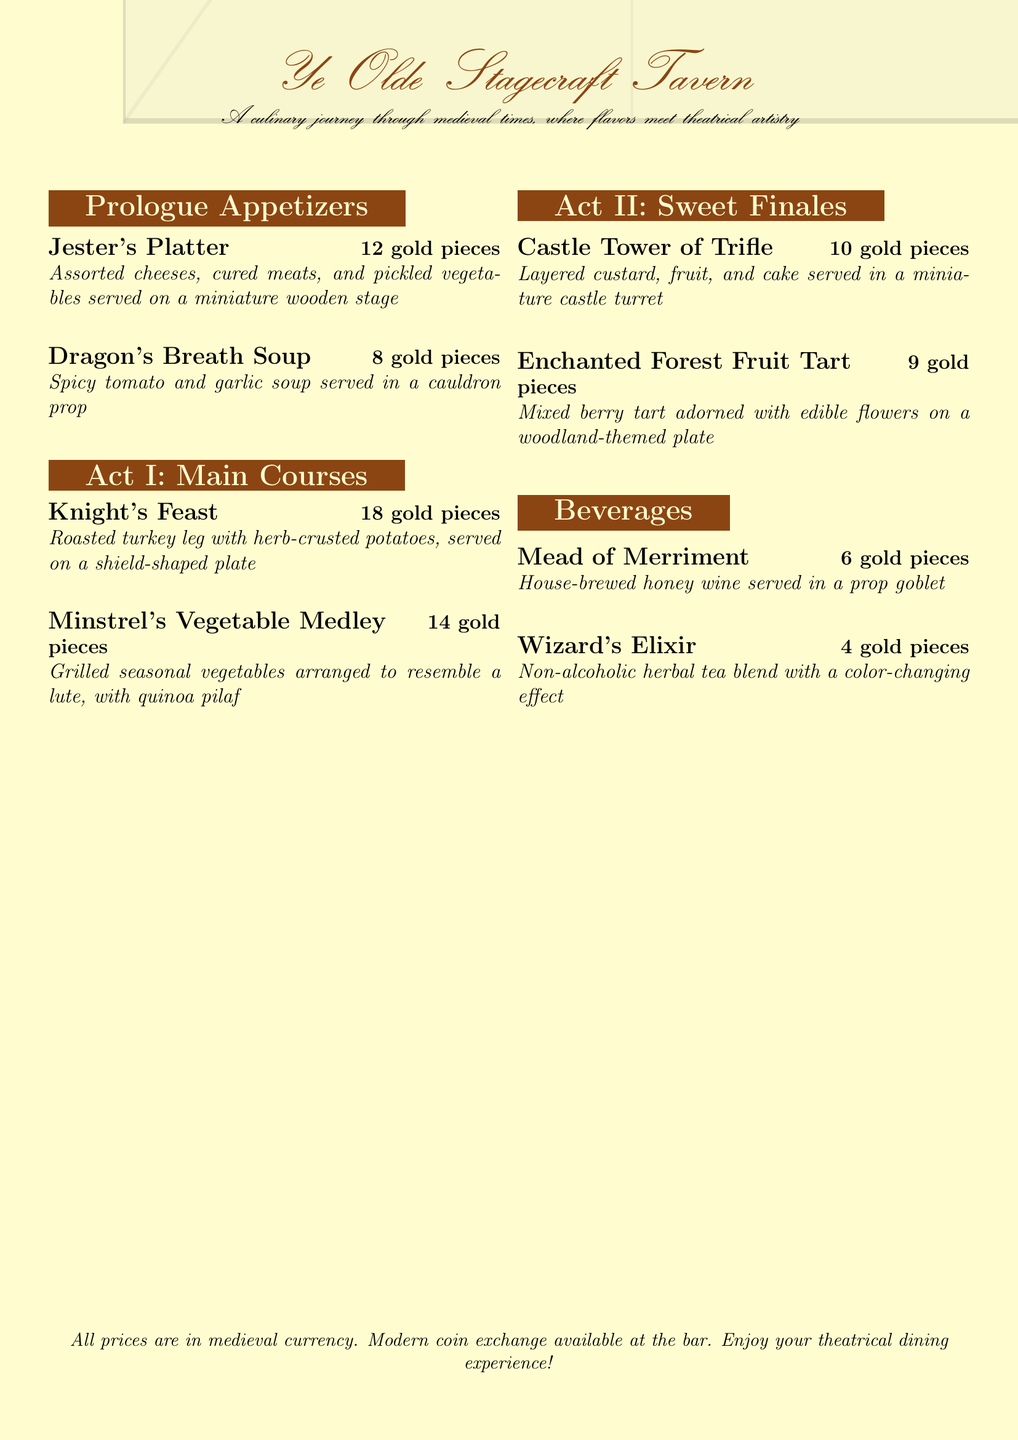What is the name of the tavern? The name of the tavern is featured prominently at the top of the document.
Answer: Ye Olde Stagecraft Tavern How many gold pieces is the Knight's Feast? The price is mentioned next to the Knight's Feast menu item.
Answer: 18 gold pieces What type of soup is served in a cauldron prop? The soup's name, as presented in the appetizers section, indicates this.
Answer: Dragon's Breath Soup What is the main ingredient of the Mead of Merriment? The drink's description includes its main ingredient.
Answer: Honey wine Which dessert resembles a castle turret? The dessert's name directly relates to its appearance as stated in the document.
Answer: Castle Tower of Trifle How many appetizers are listed? The number of appetizers can be counted from the Prologue Appetizers section.
Answer: 2 What is the price of the Enchanted Forest Fruit Tart? The price is listed next to the dessert item in the menu.
Answer: 9 gold pieces What theme is the beverage Wizard's Elixir associated with? The name of the beverage points to its theme, indicating it is herbal and magical.
Answer: Color-changing What serves as the plate for the Minstrel's Vegetable Medley? The description of the main course provides its serving plate's shape.
Answer: A lute 